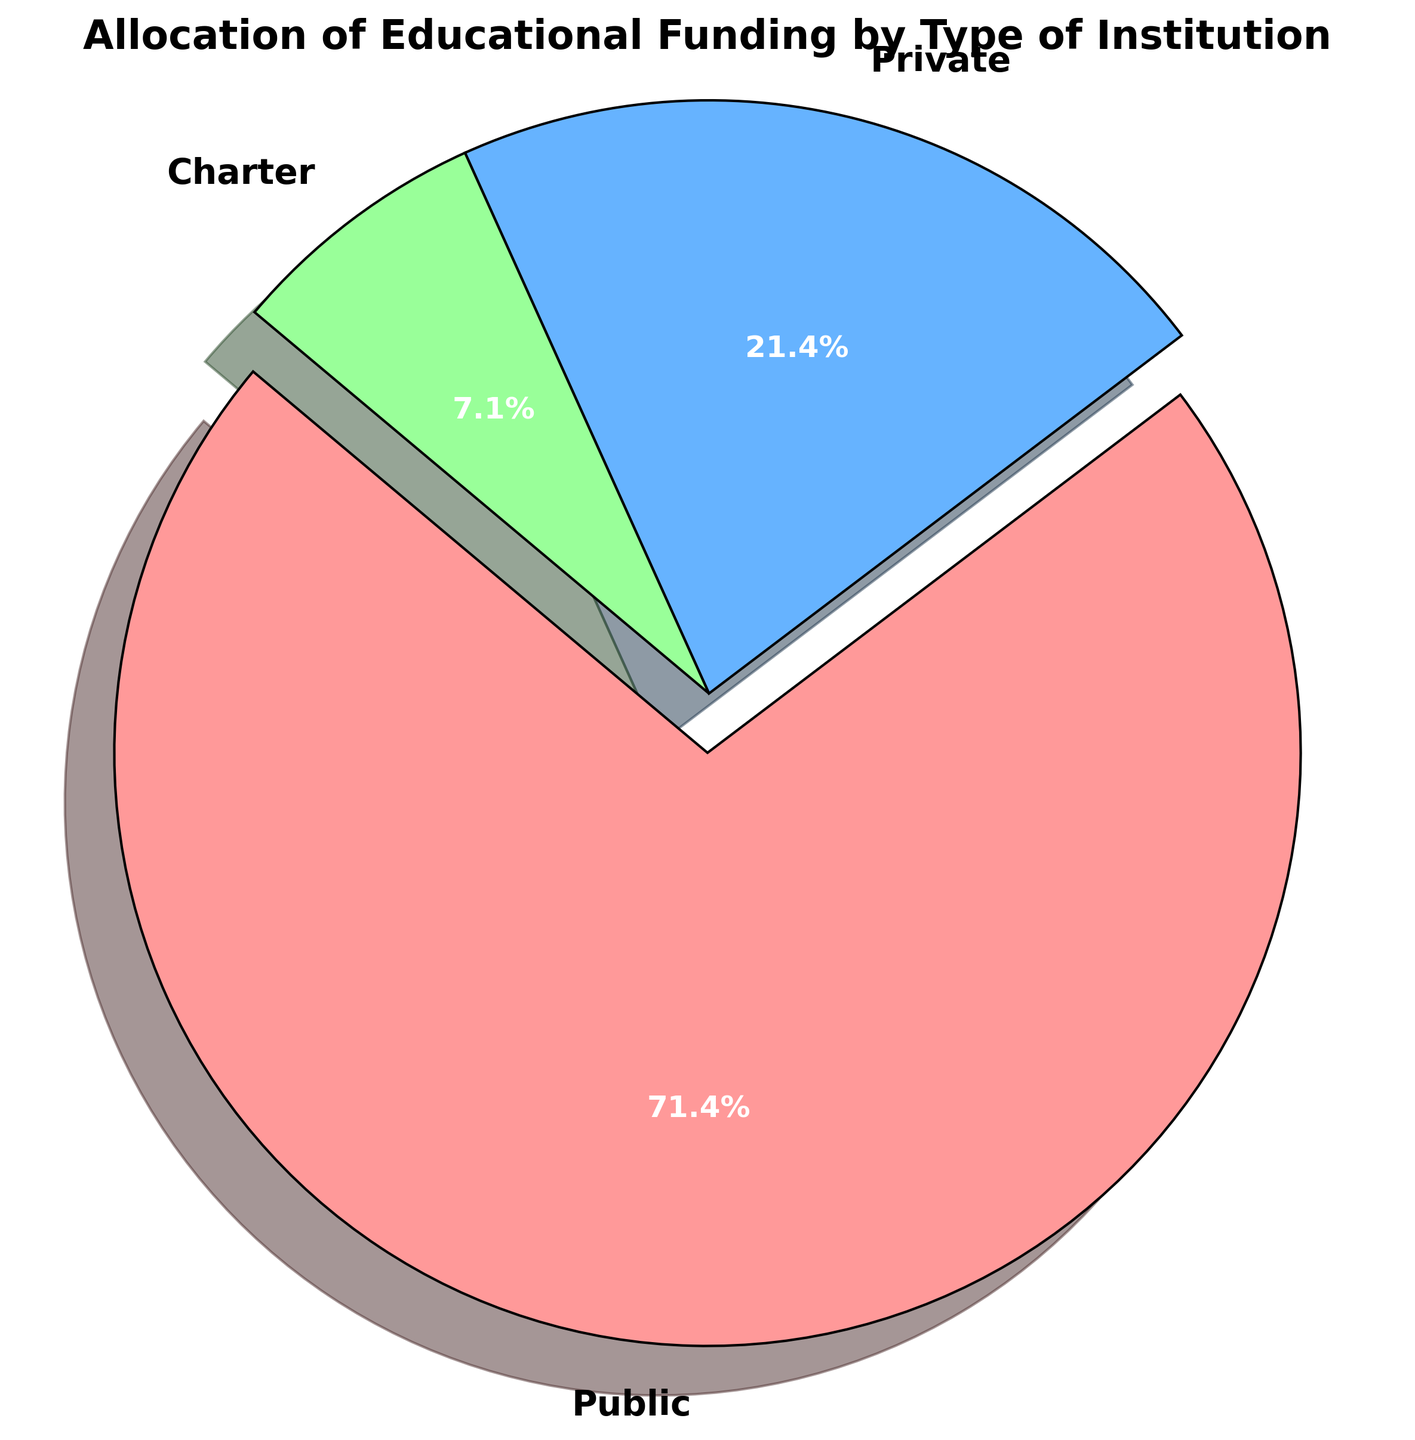Which institution type receives the highest funding? The pie chart segments are labeled with their respective funding allocations. The segment labeled "Public" is exploded and appears to be the largest.
Answer: Public How much more funding does Public receive compared to Private? The Public institution receives $500 billion, while the Private institution receives $150 billion. The difference is $500 billion - $150 billion.
Answer: $350 billion What percentage of the total funding goes to Charter institutions? The pie chart includes percentages; the segment labeled "Charter" shows 7.7%, representing the Charter institutions' share of the total funding.
Answer: 7.7% How do the sizes of the segments for Public and Private institutions compare? The segment for Public institutions is significantly larger than that for Private institutions. The sizes in billions are $500 billion for Public and $150 billion for Private.
Answer: Public is larger What is the combined funding for Private and Charter institutions? Adding the funding amounts for Private ($150 billion) and Charter ($50 billion) institutions yields $150 billion + $50 billion.
Answer: $200 billion Which institution type has the least amount of funding? The smallest segment in the pie chart is labeled "Charter," indicating it has the least funding.
Answer: Charter If the total educational funding increased to $800 billion while maintaining the same distribution, what would be the new allocation for Private institutions? The Private institutions currently receive $150 billion out of a total of $700 billion. The new total is $800 billion, maintaining the same distribution percentage (150/700 = 0.2143). The new allocation would be 0.2143 * $800 billion.
Answer: $171.4 billion What is the percentage difference in funding between Charter and Private institutions? Charter receives $50 billion and Private receives $150 billion. The difference in funding is $150 billion - $50 billion = $100 billion. The percentage difference, relative to Charter's funding, is ($100 billion / $50 billion) * 100%.
Answer: 200% By how much would the funding allocation for Public institutions need to decrease to match that of Private institutions? Public receives $500 billion and Private receives $150 billion. To match Private, Public's allocation would need to decrease by $500 billion - $150 billion.
Answer: $350 billion What visual feature makes it clear which institution receives the largest share of funding? The segment for Public is exploded (i.e., set apart from the others), and this visual feature makes it clear that Public receives the largest share of funding.
Answer: Exploded segment 